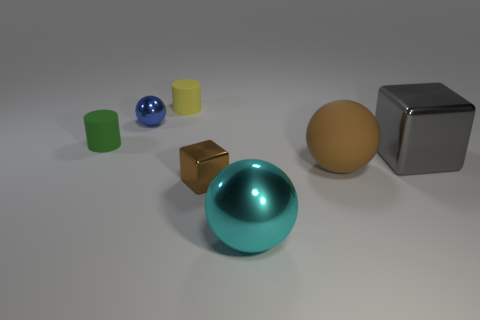What size is the other thing that is the same shape as the big gray thing?
Provide a short and direct response. Small. What is the shape of the object that is behind the brown shiny cube and in front of the gray block?
Provide a short and direct response. Sphere. Do the yellow object and the brown thing that is on the right side of the small brown metallic block have the same size?
Your answer should be compact. No. What color is the tiny thing that is the same shape as the big cyan thing?
Provide a succinct answer. Blue. There is a matte cylinder that is on the right side of the blue shiny thing; is its size the same as the matte thing that is in front of the green rubber object?
Your answer should be compact. No. Does the brown matte object have the same shape as the small yellow thing?
Ensure brevity in your answer.  No. What number of objects are spheres that are to the right of the cyan sphere or yellow shiny things?
Provide a short and direct response. 1. Is there a large brown matte object of the same shape as the large cyan object?
Your answer should be very brief. Yes. Are there the same number of gray shiny things that are left of the brown metal block and yellow metallic blocks?
Your answer should be very brief. Yes. There is a matte object that is the same color as the tiny metallic block; what shape is it?
Offer a very short reply. Sphere. 